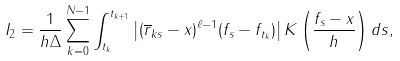<formula> <loc_0><loc_0><loc_500><loc_500>I _ { 2 } = \frac { 1 } { h \Delta } \sum _ { k = 0 } ^ { N - 1 } \int _ { t _ { k } } ^ { t _ { k + 1 } } \left | ( \overline { r } _ { k s } - x ) ^ { \ell - 1 } ( f _ { s } - f _ { t _ { k } } ) \right | K \left ( \frac { f _ { s } - x } { h } \right ) d s ,</formula> 